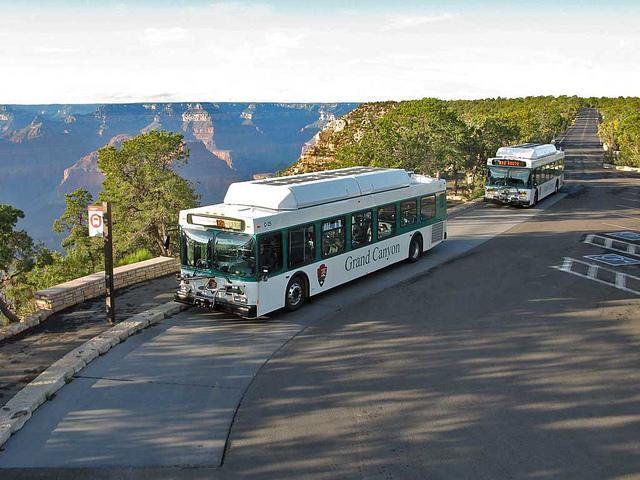How many buses are there?
Give a very brief answer. 2. 